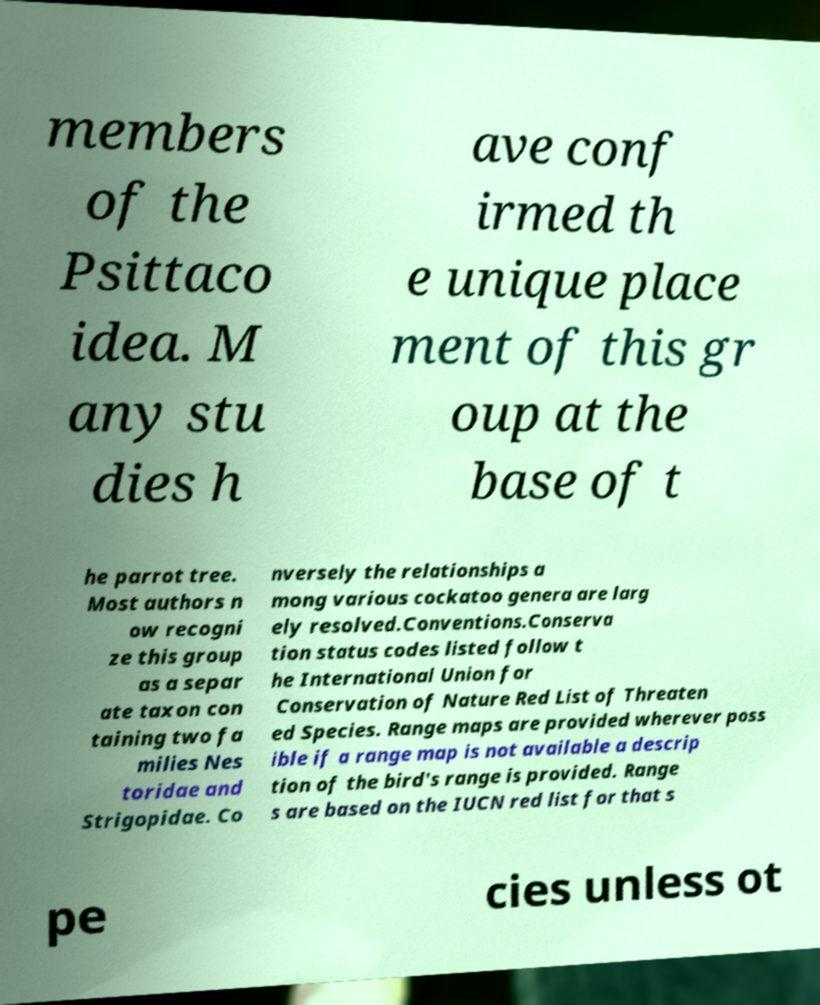I need the written content from this picture converted into text. Can you do that? members of the Psittaco idea. M any stu dies h ave conf irmed th e unique place ment of this gr oup at the base of t he parrot tree. Most authors n ow recogni ze this group as a separ ate taxon con taining two fa milies Nes toridae and Strigopidae. Co nversely the relationships a mong various cockatoo genera are larg ely resolved.Conventions.Conserva tion status codes listed follow t he International Union for Conservation of Nature Red List of Threaten ed Species. Range maps are provided wherever poss ible if a range map is not available a descrip tion of the bird's range is provided. Range s are based on the IUCN red list for that s pe cies unless ot 